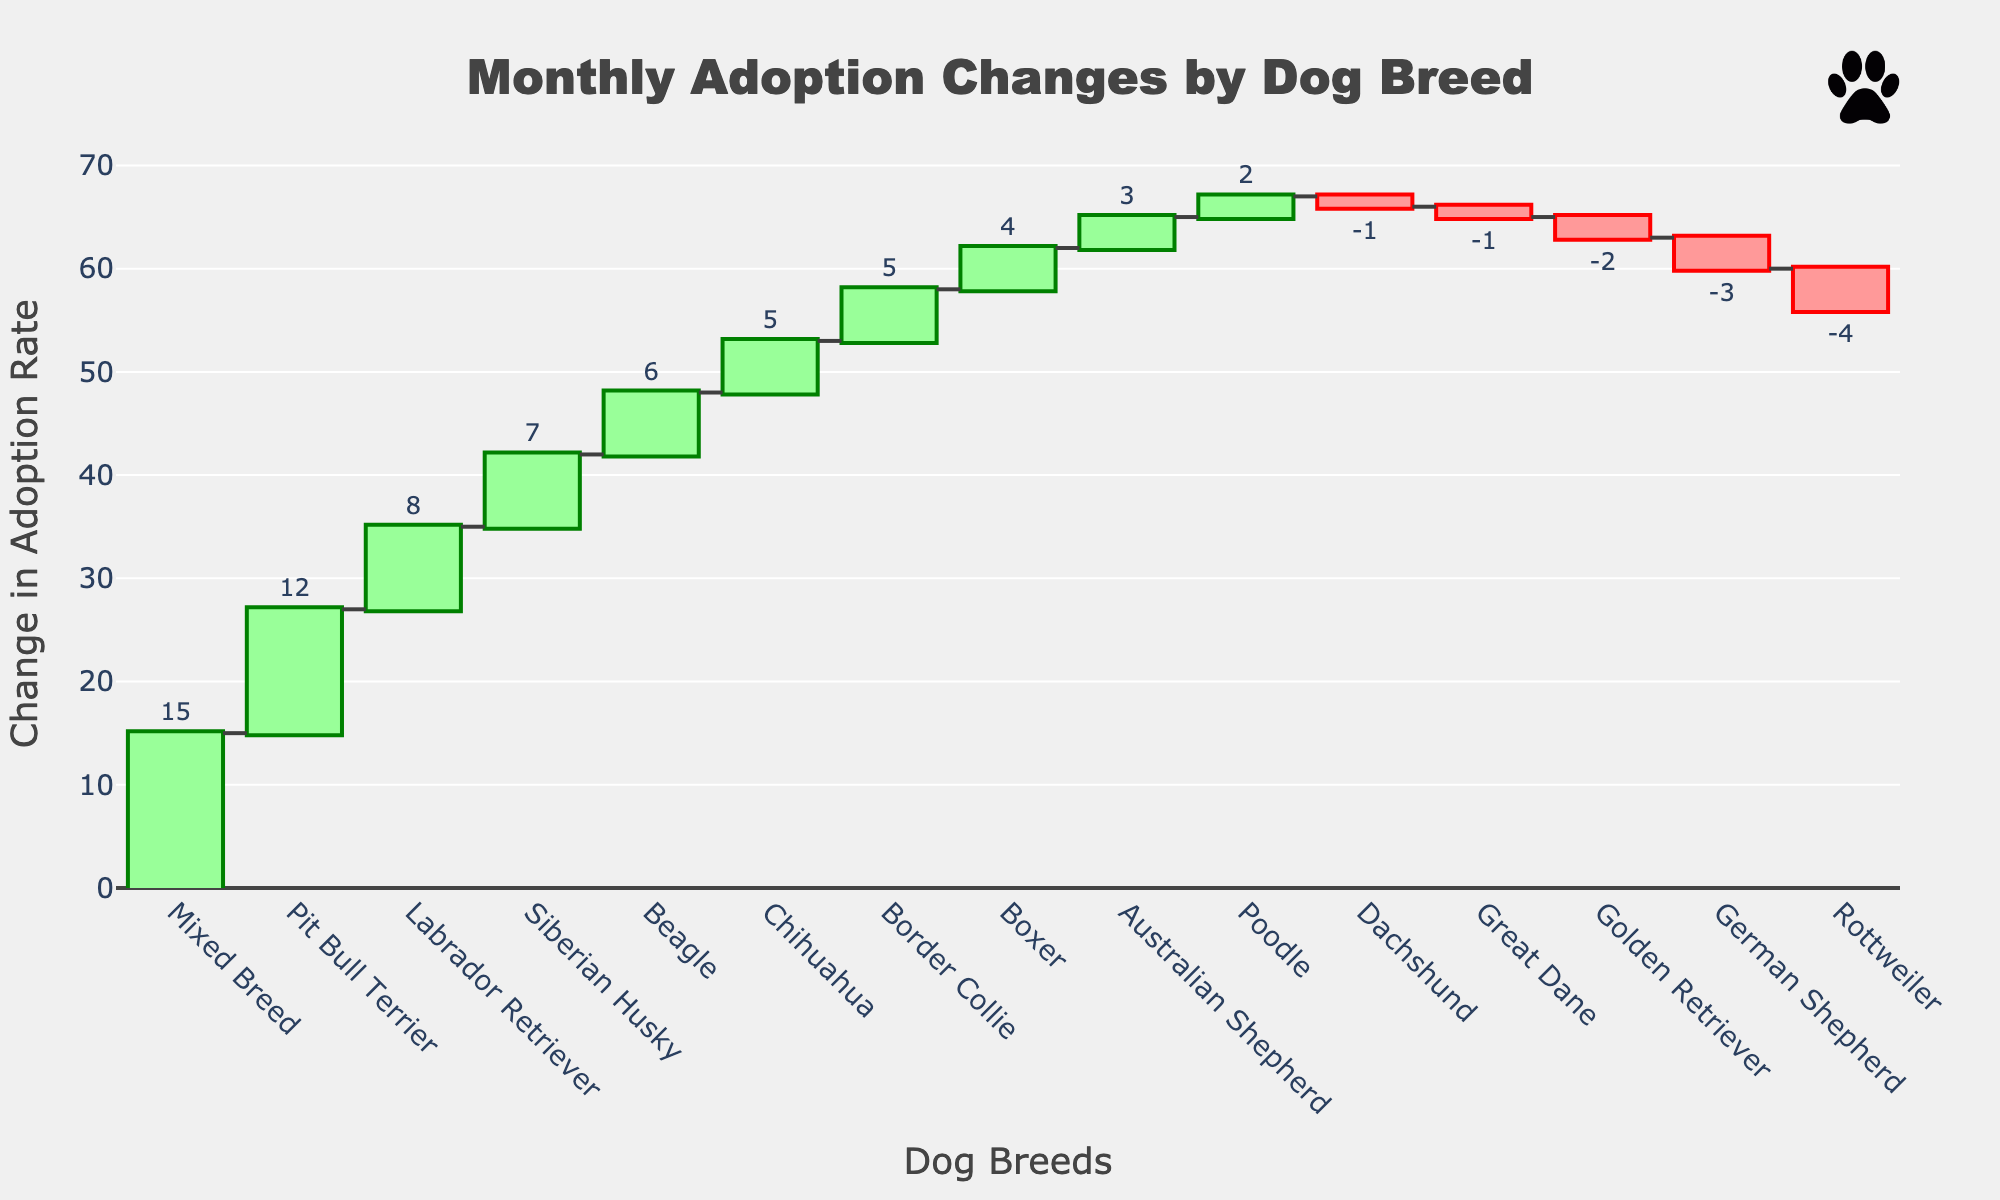What is the total number of dog breeds listed in the chart? There are 15 dog breeds listed in the chart as each breed represents a bar in the waterfall chart. Simply count the bars to get the total number.
Answer: 15 Which dog breed has the highest increase in the adoption rate? Look for the bar with the largest positive value in the chart. "Mixed Breed" has the highest increase with a change of 15.
Answer: Mixed Breed Which dog breed experienced the largest decrease in adoption rate? Identify the bar with the largest negative value in the chart. The "Rottweiler" breed has the largest decrease, with a change of -4.
Answer: Rottweiler What is the net change in adoption rates for Pit Bull Terrier, Labrador Retriever, and German Shepherd combined? Calculate the net change by summing their adoption changes: 12 (Pit Bull Terrier) + 8 (Labrador Retriever) + (-3) (German Shepherd) = 12 + 8 - 3.
Answer: 17 How many dog breeds have an increasing adoption rate? Count the number of bars with positive values. There are 11 breeds with positive values in the chart.
Answer: 11 How does the change in adoption rate for Beagles compare to the change in adoption rate for Boxers? Compare the values for Beagle (6) and Boxer (4). The adoption rate increase of Beagles is higher by 2 compared to Boxers.
Answer: Beagles: 6, Boxers: 4 Identify the dog breed with the smallest change in adoption rate. Is this change positive or negative? Find the bar with the smallest absolute value. "Golden Retriever" has the smallest change, which is -2, making it a negative change.
Answer: Golden Retriever, negative What is the total change in adoption rates for all the breeds combined? Sum all the adoption changes: 12 + 8 - 3 + 5 + 15 - 2 + 4 + 6 - 1 + 7 + 3 - 4 + 2 + 5 - 1 = 56.
Answer: 56 Among the breeds with negative changes in the adoption rate, which breed has the smallest decrease? Among negative values, the smallest absolute decrease is for "Dachshund" with -1.
Answer: Dachshund What is the average change in adoption rates for the breeds with positive changes? First, list the positive changes: 12, 8, 5, 15, 4, 6, 7, 3, 2, 5. Sum them up: 12 + 8 + 5 + 15 + 4 + 6 + 7 + 3 + 2 + 5 = 67. Then, divide by the number of positive changes (10): 67 / 10 = 6.7.
Answer: 6.7 